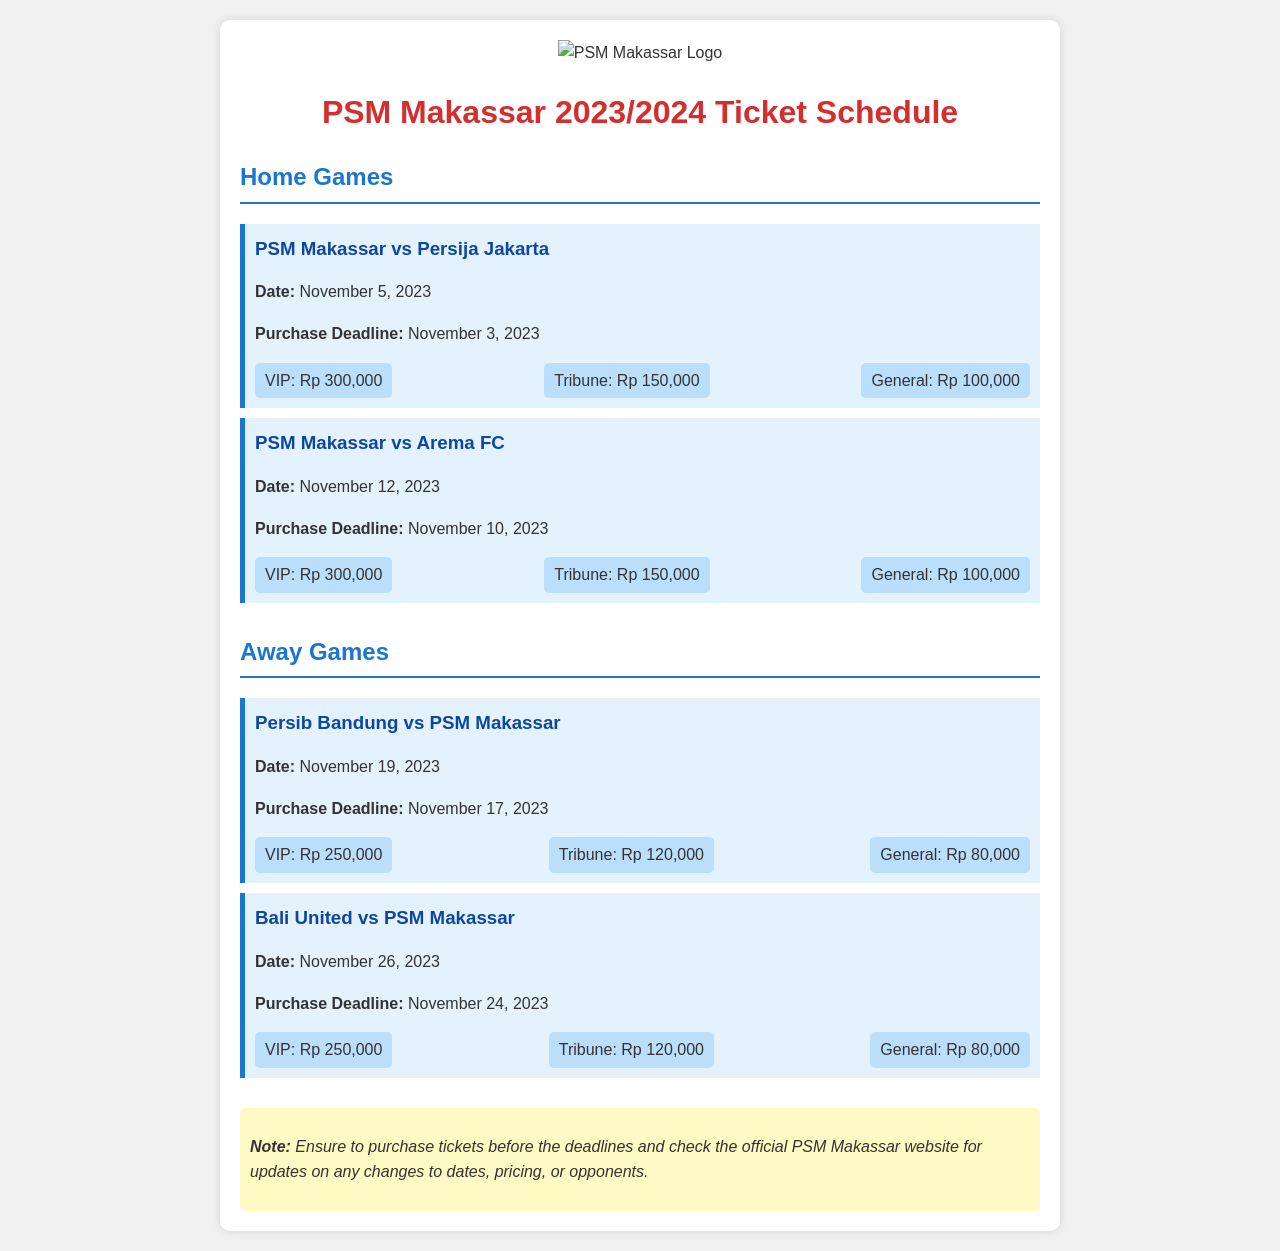What is the date of the game against Persija Jakarta? The date for the PSM Makassar vs Persija Jakarta game is mentioned in the document.
Answer: November 5, 2023 What is the purchase deadline for the game against Arema FC? The document specifies the purchase deadline for tickets to the PSM Makassar vs Arema FC game.
Answer: November 10, 2023 How much is the VIP ticket for the home game against Arema FC? The pricing breakdown for tickets to the PSM Makassar vs Arema FC game includes the cost of the VIP ticket.
Answer: Rp 300,000 What is the price of a General ticket for the away game against Bali United? The document includes the pricing for the away game tickets, specifying the price for General tickets.
Answer: Rp 80,000 Which team will PSM Makassar play away on November 19, 2023? The document lists the away game scheduled for November 19, 2023, showing the opposing team.
Answer: Persib Bandung What is the maximum price for a home game ticket? By comparing the pricing for both home games, we can identify the maximum ticket price listed for home games.
Answer: Rp 300,000 When is the away game against Bali United? The date for the away game PSM Makassar vs Bali United is provided in the schedule.
Answer: November 26, 2023 What do fans need to ensure about purchasing tickets? The document includes a note advising fans on ticket purchase.
Answer: Purchase before deadlines 